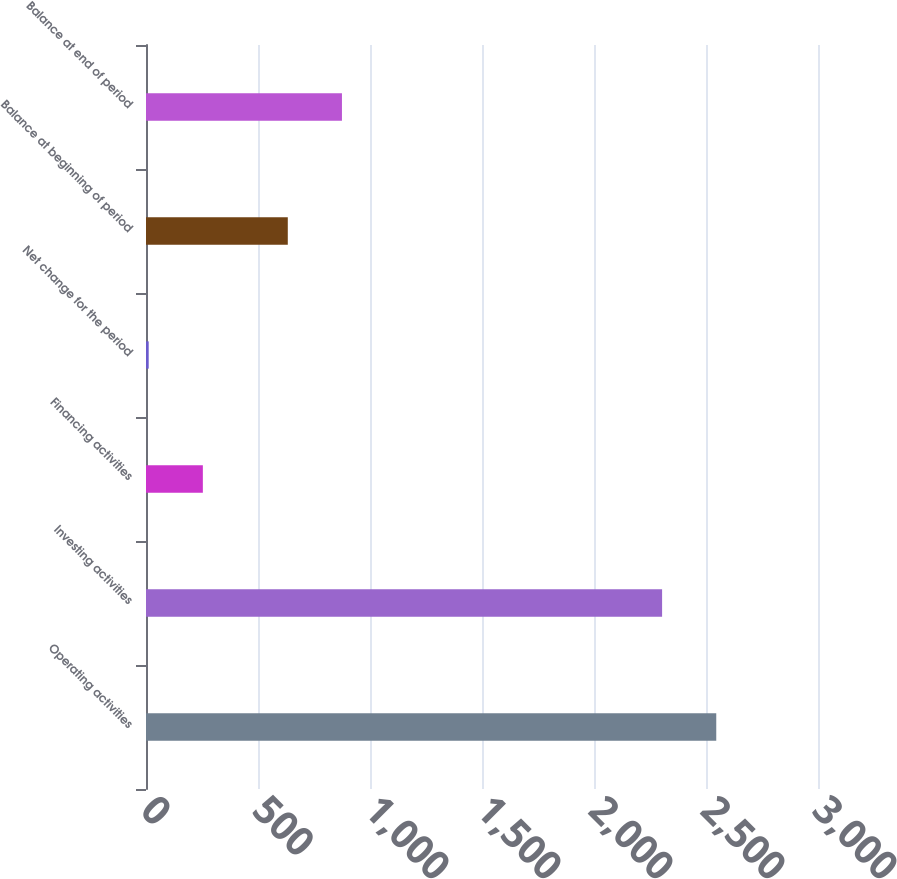Convert chart. <chart><loc_0><loc_0><loc_500><loc_500><bar_chart><fcel>Operating activities<fcel>Investing activities<fcel>Financing activities<fcel>Net change for the period<fcel>Balance at beginning of period<fcel>Balance at end of period<nl><fcel>2545.8<fcel>2304<fcel>253.8<fcel>12<fcel>633<fcel>874.8<nl></chart> 